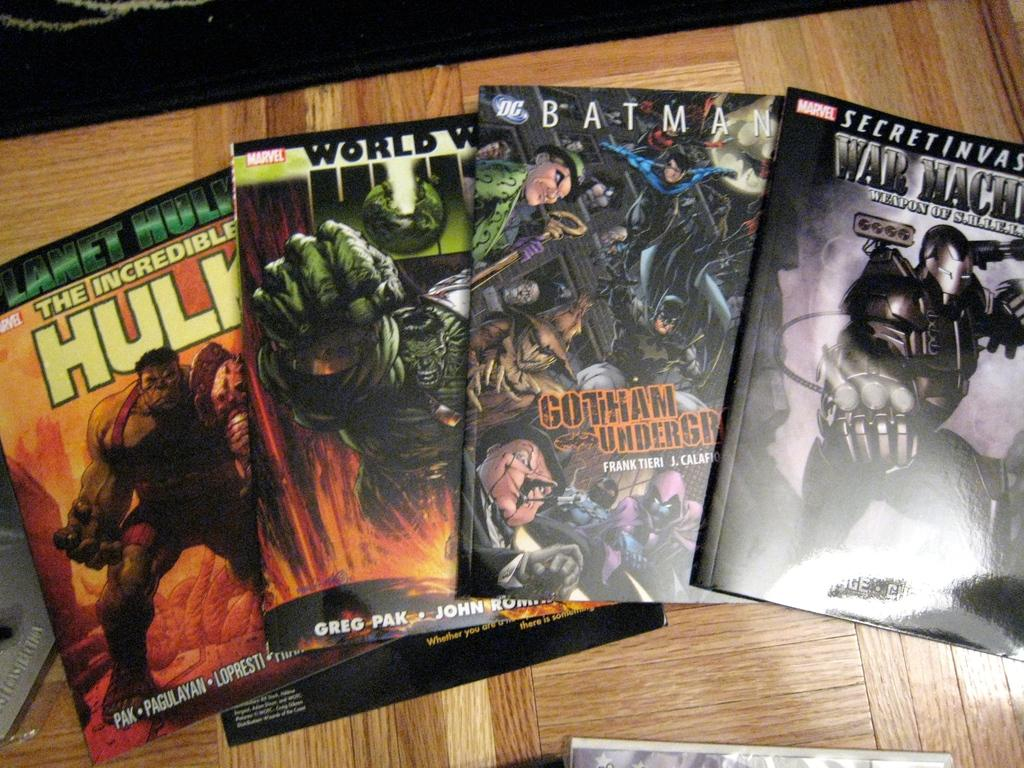Provide a one-sentence caption for the provided image. The comic book is entitled "The Incredible Hulk" and has a picture of the hulk on the cover. 